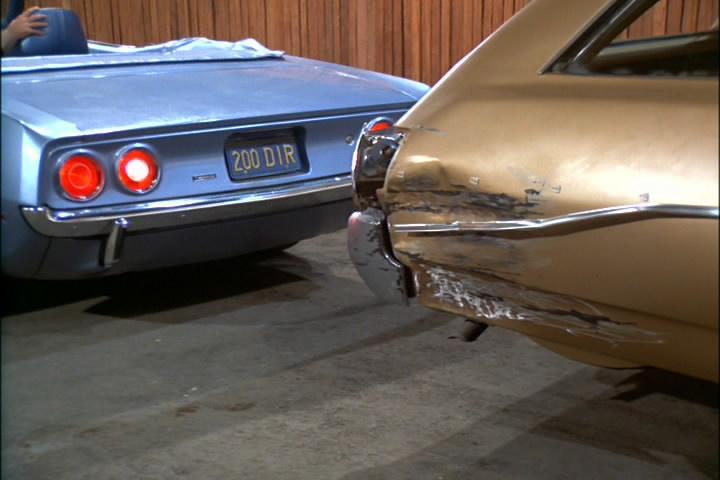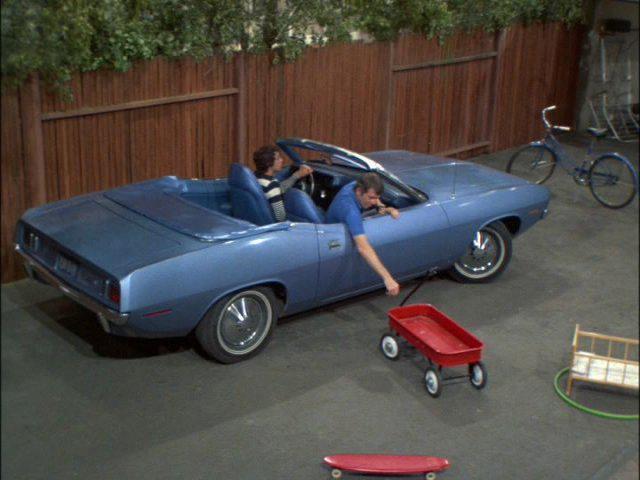The first image is the image on the left, the second image is the image on the right. Considering the images on both sides, is "There is one convertible driving down the road facing left." valid? Answer yes or no. No. 